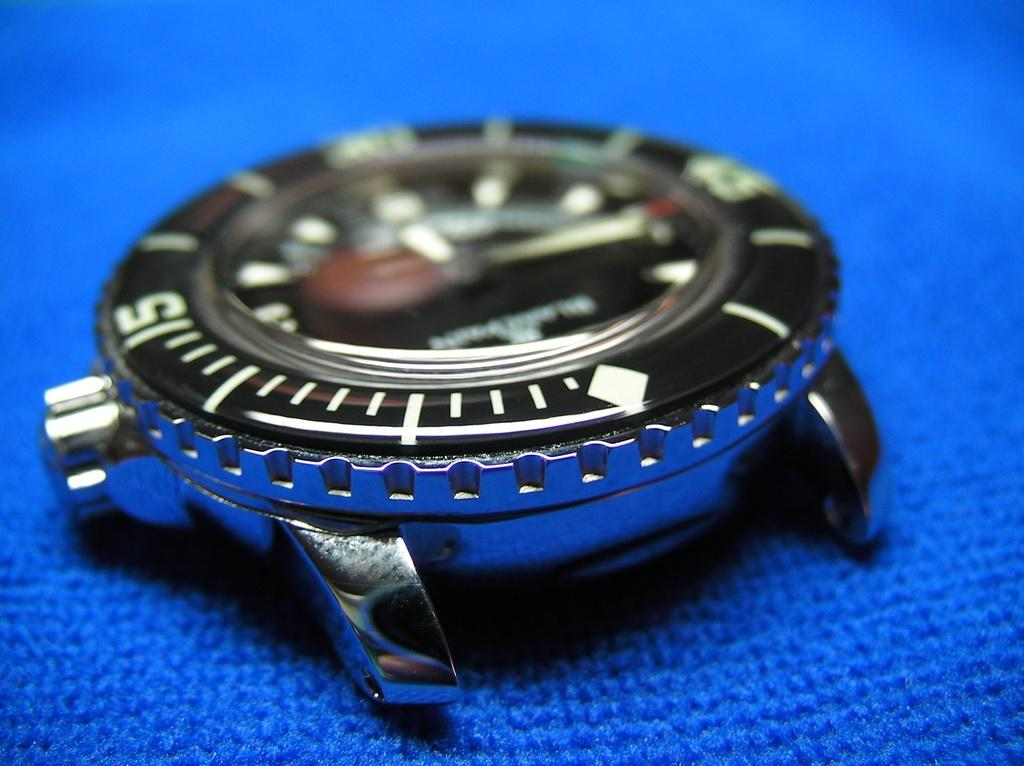<image>
Describe the image concisely. The knob on the watch is right next to the number 5, 